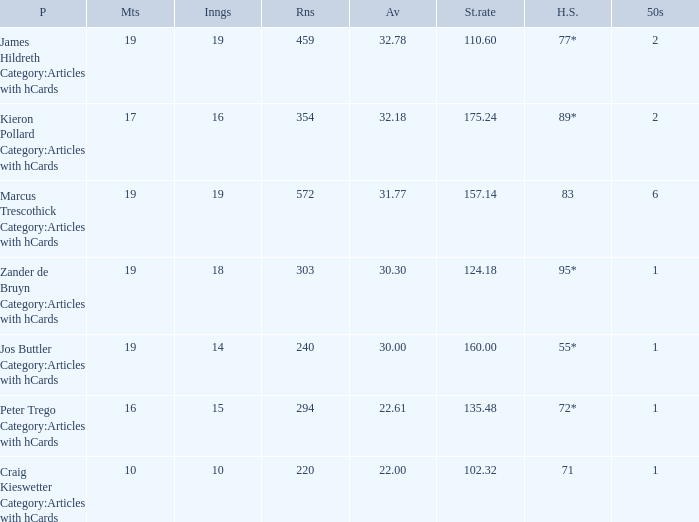How many innings for the player with an average of 22.61? 15.0. 